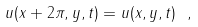Convert formula to latex. <formula><loc_0><loc_0><loc_500><loc_500>u ( x + 2 \pi , y , t ) = u ( x , y , t ) \ ,</formula> 